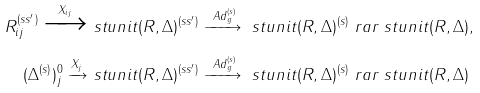<formula> <loc_0><loc_0><loc_500><loc_500>R _ { i j } ^ { ( s s ^ { \prime } ) } \xrightarrow { X _ { i j } } & \ s t u n i t ( R , \Delta ) ^ { ( s s ^ { \prime } ) } \xrightarrow { \ A d _ { g } ^ { ( s ) } } \ s t u n i t ( R , \Delta ) ^ { ( s ) } \ r a r \ s t u n i t ( R , \Delta ) , \\ ( \Delta ^ { ( s ) } ) ^ { 0 } _ { j } \xrightarrow { X _ { j } } & \ s t u n i t ( R , \Delta ) ^ { ( s s ^ { \prime } ) } \xrightarrow { \ A d _ { g } ^ { ( s ) } } \ s t u n i t ( R , \Delta ) ^ { ( s ) } \ r a r \ s t u n i t ( R , \Delta )</formula> 